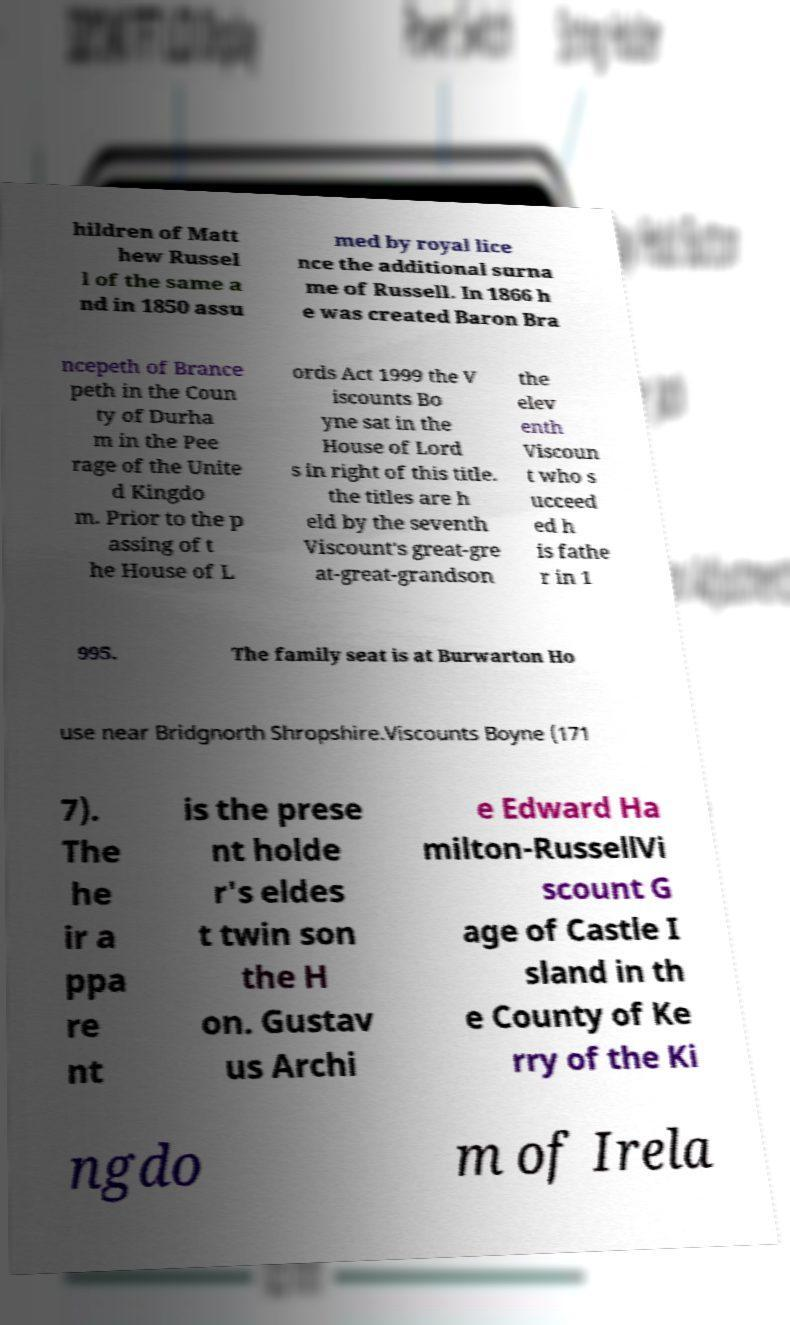Can you accurately transcribe the text from the provided image for me? hildren of Matt hew Russel l of the same a nd in 1850 assu med by royal lice nce the additional surna me of Russell. In 1866 h e was created Baron Bra ncepeth of Brance peth in the Coun ty of Durha m in the Pee rage of the Unite d Kingdo m. Prior to the p assing of t he House of L ords Act 1999 the V iscounts Bo yne sat in the House of Lord s in right of this title. the titles are h eld by the seventh Viscount's great-gre at-great-grandson the elev enth Viscoun t who s ucceed ed h is fathe r in 1 995. The family seat is at Burwarton Ho use near Bridgnorth Shropshire.Viscounts Boyne (171 7). The he ir a ppa re nt is the prese nt holde r's eldes t twin son the H on. Gustav us Archi e Edward Ha milton-RussellVi scount G age of Castle I sland in th e County of Ke rry of the Ki ngdo m of Irela 